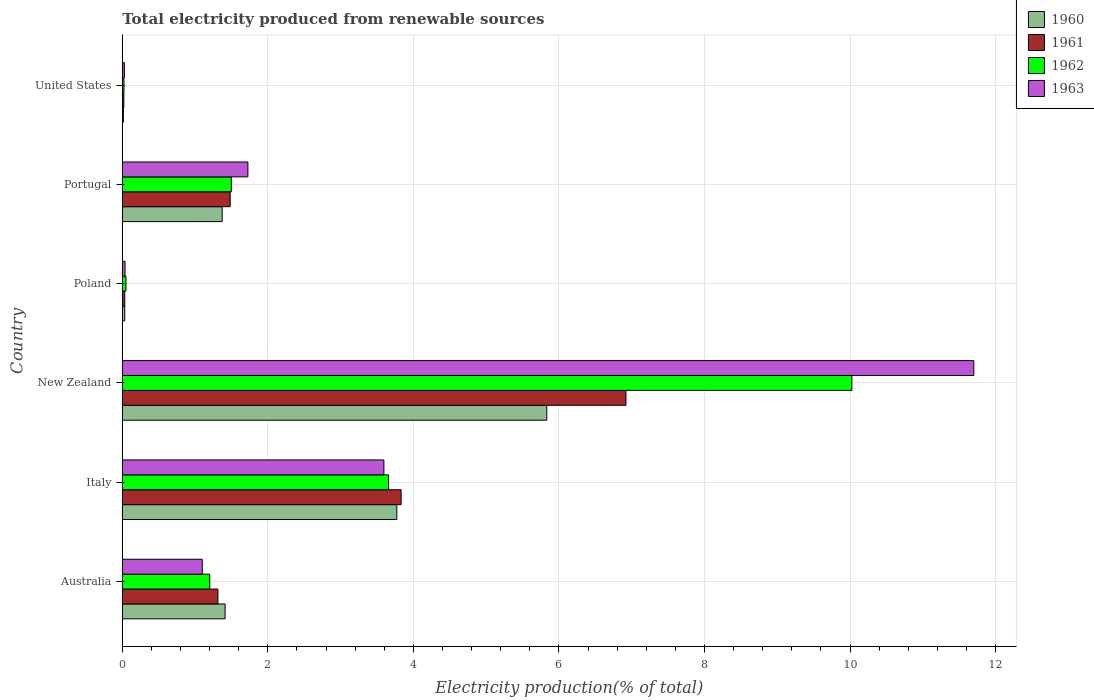Are the number of bars per tick equal to the number of legend labels?
Give a very brief answer. Yes. How many bars are there on the 2nd tick from the top?
Make the answer very short. 4. How many bars are there on the 2nd tick from the bottom?
Your answer should be compact. 4. What is the label of the 6th group of bars from the top?
Give a very brief answer. Australia. What is the total electricity produced in 1962 in United States?
Give a very brief answer. 0.02. Across all countries, what is the maximum total electricity produced in 1961?
Offer a terse response. 6.92. Across all countries, what is the minimum total electricity produced in 1963?
Offer a very short reply. 0.03. In which country was the total electricity produced in 1960 maximum?
Provide a short and direct response. New Zealand. What is the total total electricity produced in 1962 in the graph?
Keep it short and to the point. 16.46. What is the difference between the total electricity produced in 1963 in Australia and that in Poland?
Provide a succinct answer. 1.06. What is the difference between the total electricity produced in 1960 in Poland and the total electricity produced in 1961 in New Zealand?
Offer a very short reply. -6.89. What is the average total electricity produced in 1963 per country?
Your answer should be very brief. 3.03. What is the difference between the total electricity produced in 1961 and total electricity produced in 1960 in Poland?
Your answer should be very brief. -3.156606850160393e-5. What is the ratio of the total electricity produced in 1961 in Italy to that in Portugal?
Your answer should be very brief. 2.58. Is the total electricity produced in 1962 in Italy less than that in United States?
Offer a very short reply. No. What is the difference between the highest and the second highest total electricity produced in 1962?
Offer a very short reply. 6.37. What is the difference between the highest and the lowest total electricity produced in 1960?
Make the answer very short. 5.82. In how many countries, is the total electricity produced in 1960 greater than the average total electricity produced in 1960 taken over all countries?
Ensure brevity in your answer.  2. Is the sum of the total electricity produced in 1963 in Italy and New Zealand greater than the maximum total electricity produced in 1960 across all countries?
Ensure brevity in your answer.  Yes. Is it the case that in every country, the sum of the total electricity produced in 1961 and total electricity produced in 1960 is greater than the sum of total electricity produced in 1962 and total electricity produced in 1963?
Your answer should be very brief. No. Is it the case that in every country, the sum of the total electricity produced in 1963 and total electricity produced in 1962 is greater than the total electricity produced in 1960?
Provide a succinct answer. Yes. Are all the bars in the graph horizontal?
Provide a short and direct response. Yes. What is the difference between two consecutive major ticks on the X-axis?
Offer a terse response. 2. Are the values on the major ticks of X-axis written in scientific E-notation?
Provide a short and direct response. No. Where does the legend appear in the graph?
Provide a short and direct response. Top right. How are the legend labels stacked?
Offer a very short reply. Vertical. What is the title of the graph?
Your answer should be compact. Total electricity produced from renewable sources. Does "2013" appear as one of the legend labels in the graph?
Make the answer very short. No. What is the label or title of the X-axis?
Give a very brief answer. Electricity production(% of total). What is the Electricity production(% of total) of 1960 in Australia?
Offer a terse response. 1.41. What is the Electricity production(% of total) in 1961 in Australia?
Your response must be concise. 1.31. What is the Electricity production(% of total) in 1962 in Australia?
Provide a succinct answer. 1.2. What is the Electricity production(% of total) in 1963 in Australia?
Your answer should be very brief. 1.1. What is the Electricity production(% of total) of 1960 in Italy?
Your answer should be very brief. 3.77. What is the Electricity production(% of total) of 1961 in Italy?
Provide a short and direct response. 3.83. What is the Electricity production(% of total) in 1962 in Italy?
Give a very brief answer. 3.66. What is the Electricity production(% of total) of 1963 in Italy?
Your answer should be compact. 3.59. What is the Electricity production(% of total) of 1960 in New Zealand?
Offer a very short reply. 5.83. What is the Electricity production(% of total) in 1961 in New Zealand?
Provide a succinct answer. 6.92. What is the Electricity production(% of total) in 1962 in New Zealand?
Offer a terse response. 10.02. What is the Electricity production(% of total) of 1963 in New Zealand?
Provide a succinct answer. 11.7. What is the Electricity production(% of total) of 1960 in Poland?
Your answer should be very brief. 0.03. What is the Electricity production(% of total) in 1961 in Poland?
Offer a very short reply. 0.03. What is the Electricity production(% of total) of 1962 in Poland?
Keep it short and to the point. 0.05. What is the Electricity production(% of total) of 1963 in Poland?
Your answer should be very brief. 0.04. What is the Electricity production(% of total) of 1960 in Portugal?
Provide a succinct answer. 1.37. What is the Electricity production(% of total) in 1961 in Portugal?
Give a very brief answer. 1.48. What is the Electricity production(% of total) in 1962 in Portugal?
Provide a short and direct response. 1.5. What is the Electricity production(% of total) of 1963 in Portugal?
Your response must be concise. 1.73. What is the Electricity production(% of total) of 1960 in United States?
Offer a very short reply. 0.02. What is the Electricity production(% of total) in 1961 in United States?
Offer a very short reply. 0.02. What is the Electricity production(% of total) of 1962 in United States?
Ensure brevity in your answer.  0.02. What is the Electricity production(% of total) of 1963 in United States?
Provide a short and direct response. 0.03. Across all countries, what is the maximum Electricity production(% of total) of 1960?
Provide a succinct answer. 5.83. Across all countries, what is the maximum Electricity production(% of total) of 1961?
Ensure brevity in your answer.  6.92. Across all countries, what is the maximum Electricity production(% of total) of 1962?
Provide a short and direct response. 10.02. Across all countries, what is the maximum Electricity production(% of total) of 1963?
Your answer should be very brief. 11.7. Across all countries, what is the minimum Electricity production(% of total) in 1960?
Offer a very short reply. 0.02. Across all countries, what is the minimum Electricity production(% of total) of 1961?
Give a very brief answer. 0.02. Across all countries, what is the minimum Electricity production(% of total) in 1962?
Offer a terse response. 0.02. Across all countries, what is the minimum Electricity production(% of total) of 1963?
Offer a very short reply. 0.03. What is the total Electricity production(% of total) in 1960 in the graph?
Provide a succinct answer. 12.44. What is the total Electricity production(% of total) in 1961 in the graph?
Ensure brevity in your answer.  13.6. What is the total Electricity production(% of total) in 1962 in the graph?
Ensure brevity in your answer.  16.46. What is the total Electricity production(% of total) of 1963 in the graph?
Your answer should be compact. 18.19. What is the difference between the Electricity production(% of total) in 1960 in Australia and that in Italy?
Offer a terse response. -2.36. What is the difference between the Electricity production(% of total) of 1961 in Australia and that in Italy?
Provide a succinct answer. -2.52. What is the difference between the Electricity production(% of total) in 1962 in Australia and that in Italy?
Give a very brief answer. -2.46. What is the difference between the Electricity production(% of total) of 1963 in Australia and that in Italy?
Provide a succinct answer. -2.5. What is the difference between the Electricity production(% of total) of 1960 in Australia and that in New Zealand?
Your answer should be very brief. -4.42. What is the difference between the Electricity production(% of total) of 1961 in Australia and that in New Zealand?
Your answer should be compact. -5.61. What is the difference between the Electricity production(% of total) in 1962 in Australia and that in New Zealand?
Make the answer very short. -8.82. What is the difference between the Electricity production(% of total) in 1963 in Australia and that in New Zealand?
Ensure brevity in your answer.  -10.6. What is the difference between the Electricity production(% of total) of 1960 in Australia and that in Poland?
Your response must be concise. 1.38. What is the difference between the Electricity production(% of total) of 1961 in Australia and that in Poland?
Your answer should be compact. 1.28. What is the difference between the Electricity production(% of total) of 1962 in Australia and that in Poland?
Make the answer very short. 1.15. What is the difference between the Electricity production(% of total) in 1963 in Australia and that in Poland?
Provide a succinct answer. 1.06. What is the difference between the Electricity production(% of total) in 1960 in Australia and that in Portugal?
Offer a very short reply. 0.04. What is the difference between the Electricity production(% of total) in 1961 in Australia and that in Portugal?
Offer a very short reply. -0.17. What is the difference between the Electricity production(% of total) in 1962 in Australia and that in Portugal?
Your response must be concise. -0.3. What is the difference between the Electricity production(% of total) in 1963 in Australia and that in Portugal?
Make the answer very short. -0.63. What is the difference between the Electricity production(% of total) of 1960 in Australia and that in United States?
Give a very brief answer. 1.4. What is the difference between the Electricity production(% of total) of 1961 in Australia and that in United States?
Make the answer very short. 1.29. What is the difference between the Electricity production(% of total) of 1962 in Australia and that in United States?
Make the answer very short. 1.18. What is the difference between the Electricity production(% of total) of 1963 in Australia and that in United States?
Ensure brevity in your answer.  1.07. What is the difference between the Electricity production(% of total) in 1960 in Italy and that in New Zealand?
Your answer should be very brief. -2.06. What is the difference between the Electricity production(% of total) of 1961 in Italy and that in New Zealand?
Your answer should be compact. -3.09. What is the difference between the Electricity production(% of total) in 1962 in Italy and that in New Zealand?
Keep it short and to the point. -6.37. What is the difference between the Electricity production(% of total) of 1963 in Italy and that in New Zealand?
Your answer should be compact. -8.11. What is the difference between the Electricity production(% of total) of 1960 in Italy and that in Poland?
Make the answer very short. 3.74. What is the difference between the Electricity production(% of total) of 1961 in Italy and that in Poland?
Your answer should be very brief. 3.8. What is the difference between the Electricity production(% of total) in 1962 in Italy and that in Poland?
Your answer should be compact. 3.61. What is the difference between the Electricity production(% of total) of 1963 in Italy and that in Poland?
Offer a terse response. 3.56. What is the difference between the Electricity production(% of total) in 1960 in Italy and that in Portugal?
Your answer should be compact. 2.4. What is the difference between the Electricity production(% of total) of 1961 in Italy and that in Portugal?
Keep it short and to the point. 2.35. What is the difference between the Electricity production(% of total) in 1962 in Italy and that in Portugal?
Ensure brevity in your answer.  2.16. What is the difference between the Electricity production(% of total) of 1963 in Italy and that in Portugal?
Provide a succinct answer. 1.87. What is the difference between the Electricity production(% of total) in 1960 in Italy and that in United States?
Provide a succinct answer. 3.76. What is the difference between the Electricity production(% of total) of 1961 in Italy and that in United States?
Ensure brevity in your answer.  3.81. What is the difference between the Electricity production(% of total) of 1962 in Italy and that in United States?
Give a very brief answer. 3.64. What is the difference between the Electricity production(% of total) in 1963 in Italy and that in United States?
Your response must be concise. 3.56. What is the difference between the Electricity production(% of total) in 1960 in New Zealand and that in Poland?
Offer a terse response. 5.8. What is the difference between the Electricity production(% of total) of 1961 in New Zealand and that in Poland?
Provide a short and direct response. 6.89. What is the difference between the Electricity production(% of total) in 1962 in New Zealand and that in Poland?
Give a very brief answer. 9.97. What is the difference between the Electricity production(% of total) in 1963 in New Zealand and that in Poland?
Your response must be concise. 11.66. What is the difference between the Electricity production(% of total) of 1960 in New Zealand and that in Portugal?
Ensure brevity in your answer.  4.46. What is the difference between the Electricity production(% of total) of 1961 in New Zealand and that in Portugal?
Make the answer very short. 5.44. What is the difference between the Electricity production(% of total) in 1962 in New Zealand and that in Portugal?
Make the answer very short. 8.53. What is the difference between the Electricity production(% of total) in 1963 in New Zealand and that in Portugal?
Offer a terse response. 9.97. What is the difference between the Electricity production(% of total) in 1960 in New Zealand and that in United States?
Provide a short and direct response. 5.82. What is the difference between the Electricity production(% of total) in 1961 in New Zealand and that in United States?
Your answer should be compact. 6.9. What is the difference between the Electricity production(% of total) of 1962 in New Zealand and that in United States?
Offer a terse response. 10. What is the difference between the Electricity production(% of total) of 1963 in New Zealand and that in United States?
Make the answer very short. 11.67. What is the difference between the Electricity production(% of total) in 1960 in Poland and that in Portugal?
Keep it short and to the point. -1.34. What is the difference between the Electricity production(% of total) in 1961 in Poland and that in Portugal?
Make the answer very short. -1.45. What is the difference between the Electricity production(% of total) in 1962 in Poland and that in Portugal?
Keep it short and to the point. -1.45. What is the difference between the Electricity production(% of total) of 1963 in Poland and that in Portugal?
Your response must be concise. -1.69. What is the difference between the Electricity production(% of total) of 1960 in Poland and that in United States?
Your response must be concise. 0.02. What is the difference between the Electricity production(% of total) of 1961 in Poland and that in United States?
Offer a very short reply. 0.01. What is the difference between the Electricity production(% of total) in 1962 in Poland and that in United States?
Your response must be concise. 0.03. What is the difference between the Electricity production(% of total) of 1963 in Poland and that in United States?
Offer a terse response. 0.01. What is the difference between the Electricity production(% of total) of 1960 in Portugal and that in United States?
Your answer should be very brief. 1.36. What is the difference between the Electricity production(% of total) of 1961 in Portugal and that in United States?
Your answer should be compact. 1.46. What is the difference between the Electricity production(% of total) in 1962 in Portugal and that in United States?
Ensure brevity in your answer.  1.48. What is the difference between the Electricity production(% of total) of 1963 in Portugal and that in United States?
Your response must be concise. 1.7. What is the difference between the Electricity production(% of total) of 1960 in Australia and the Electricity production(% of total) of 1961 in Italy?
Your answer should be very brief. -2.42. What is the difference between the Electricity production(% of total) of 1960 in Australia and the Electricity production(% of total) of 1962 in Italy?
Your answer should be very brief. -2.25. What is the difference between the Electricity production(% of total) in 1960 in Australia and the Electricity production(% of total) in 1963 in Italy?
Make the answer very short. -2.18. What is the difference between the Electricity production(% of total) of 1961 in Australia and the Electricity production(% of total) of 1962 in Italy?
Ensure brevity in your answer.  -2.34. What is the difference between the Electricity production(% of total) of 1961 in Australia and the Electricity production(% of total) of 1963 in Italy?
Keep it short and to the point. -2.28. What is the difference between the Electricity production(% of total) in 1962 in Australia and the Electricity production(% of total) in 1963 in Italy?
Give a very brief answer. -2.39. What is the difference between the Electricity production(% of total) in 1960 in Australia and the Electricity production(% of total) in 1961 in New Zealand?
Your answer should be very brief. -5.51. What is the difference between the Electricity production(% of total) in 1960 in Australia and the Electricity production(% of total) in 1962 in New Zealand?
Your answer should be very brief. -8.61. What is the difference between the Electricity production(% of total) of 1960 in Australia and the Electricity production(% of total) of 1963 in New Zealand?
Keep it short and to the point. -10.29. What is the difference between the Electricity production(% of total) in 1961 in Australia and the Electricity production(% of total) in 1962 in New Zealand?
Offer a terse response. -8.71. What is the difference between the Electricity production(% of total) in 1961 in Australia and the Electricity production(% of total) in 1963 in New Zealand?
Offer a terse response. -10.39. What is the difference between the Electricity production(% of total) in 1962 in Australia and the Electricity production(% of total) in 1963 in New Zealand?
Your answer should be compact. -10.5. What is the difference between the Electricity production(% of total) of 1960 in Australia and the Electricity production(% of total) of 1961 in Poland?
Give a very brief answer. 1.38. What is the difference between the Electricity production(% of total) in 1960 in Australia and the Electricity production(% of total) in 1962 in Poland?
Offer a terse response. 1.36. What is the difference between the Electricity production(% of total) in 1960 in Australia and the Electricity production(% of total) in 1963 in Poland?
Make the answer very short. 1.37. What is the difference between the Electricity production(% of total) of 1961 in Australia and the Electricity production(% of total) of 1962 in Poland?
Your response must be concise. 1.26. What is the difference between the Electricity production(% of total) of 1961 in Australia and the Electricity production(% of total) of 1963 in Poland?
Keep it short and to the point. 1.28. What is the difference between the Electricity production(% of total) of 1962 in Australia and the Electricity production(% of total) of 1963 in Poland?
Provide a succinct answer. 1.16. What is the difference between the Electricity production(% of total) of 1960 in Australia and the Electricity production(% of total) of 1961 in Portugal?
Keep it short and to the point. -0.07. What is the difference between the Electricity production(% of total) in 1960 in Australia and the Electricity production(% of total) in 1962 in Portugal?
Your answer should be compact. -0.09. What is the difference between the Electricity production(% of total) of 1960 in Australia and the Electricity production(% of total) of 1963 in Portugal?
Make the answer very short. -0.31. What is the difference between the Electricity production(% of total) in 1961 in Australia and the Electricity production(% of total) in 1962 in Portugal?
Provide a succinct answer. -0.18. What is the difference between the Electricity production(% of total) of 1961 in Australia and the Electricity production(% of total) of 1963 in Portugal?
Provide a short and direct response. -0.41. What is the difference between the Electricity production(% of total) of 1962 in Australia and the Electricity production(% of total) of 1963 in Portugal?
Your answer should be very brief. -0.52. What is the difference between the Electricity production(% of total) of 1960 in Australia and the Electricity production(% of total) of 1961 in United States?
Your response must be concise. 1.39. What is the difference between the Electricity production(% of total) in 1960 in Australia and the Electricity production(% of total) in 1962 in United States?
Your response must be concise. 1.39. What is the difference between the Electricity production(% of total) in 1960 in Australia and the Electricity production(% of total) in 1963 in United States?
Ensure brevity in your answer.  1.38. What is the difference between the Electricity production(% of total) of 1961 in Australia and the Electricity production(% of total) of 1962 in United States?
Your response must be concise. 1.29. What is the difference between the Electricity production(% of total) of 1961 in Australia and the Electricity production(% of total) of 1963 in United States?
Offer a terse response. 1.28. What is the difference between the Electricity production(% of total) of 1962 in Australia and the Electricity production(% of total) of 1963 in United States?
Ensure brevity in your answer.  1.17. What is the difference between the Electricity production(% of total) of 1960 in Italy and the Electricity production(% of total) of 1961 in New Zealand?
Offer a very short reply. -3.15. What is the difference between the Electricity production(% of total) in 1960 in Italy and the Electricity production(% of total) in 1962 in New Zealand?
Your answer should be compact. -6.25. What is the difference between the Electricity production(% of total) of 1960 in Italy and the Electricity production(% of total) of 1963 in New Zealand?
Ensure brevity in your answer.  -7.93. What is the difference between the Electricity production(% of total) of 1961 in Italy and the Electricity production(% of total) of 1962 in New Zealand?
Provide a succinct answer. -6.19. What is the difference between the Electricity production(% of total) of 1961 in Italy and the Electricity production(% of total) of 1963 in New Zealand?
Your answer should be very brief. -7.87. What is the difference between the Electricity production(% of total) of 1962 in Italy and the Electricity production(% of total) of 1963 in New Zealand?
Ensure brevity in your answer.  -8.04. What is the difference between the Electricity production(% of total) in 1960 in Italy and the Electricity production(% of total) in 1961 in Poland?
Give a very brief answer. 3.74. What is the difference between the Electricity production(% of total) of 1960 in Italy and the Electricity production(% of total) of 1962 in Poland?
Offer a very short reply. 3.72. What is the difference between the Electricity production(% of total) of 1960 in Italy and the Electricity production(% of total) of 1963 in Poland?
Keep it short and to the point. 3.73. What is the difference between the Electricity production(% of total) of 1961 in Italy and the Electricity production(% of total) of 1962 in Poland?
Keep it short and to the point. 3.78. What is the difference between the Electricity production(% of total) of 1961 in Italy and the Electricity production(% of total) of 1963 in Poland?
Make the answer very short. 3.79. What is the difference between the Electricity production(% of total) in 1962 in Italy and the Electricity production(% of total) in 1963 in Poland?
Make the answer very short. 3.62. What is the difference between the Electricity production(% of total) of 1960 in Italy and the Electricity production(% of total) of 1961 in Portugal?
Your response must be concise. 2.29. What is the difference between the Electricity production(% of total) of 1960 in Italy and the Electricity production(% of total) of 1962 in Portugal?
Provide a succinct answer. 2.27. What is the difference between the Electricity production(% of total) in 1960 in Italy and the Electricity production(% of total) in 1963 in Portugal?
Make the answer very short. 2.05. What is the difference between the Electricity production(% of total) of 1961 in Italy and the Electricity production(% of total) of 1962 in Portugal?
Make the answer very short. 2.33. What is the difference between the Electricity production(% of total) in 1961 in Italy and the Electricity production(% of total) in 1963 in Portugal?
Provide a short and direct response. 2.11. What is the difference between the Electricity production(% of total) of 1962 in Italy and the Electricity production(% of total) of 1963 in Portugal?
Your answer should be compact. 1.93. What is the difference between the Electricity production(% of total) in 1960 in Italy and the Electricity production(% of total) in 1961 in United States?
Ensure brevity in your answer.  3.75. What is the difference between the Electricity production(% of total) in 1960 in Italy and the Electricity production(% of total) in 1962 in United States?
Your answer should be compact. 3.75. What is the difference between the Electricity production(% of total) of 1960 in Italy and the Electricity production(% of total) of 1963 in United States?
Your answer should be compact. 3.74. What is the difference between the Electricity production(% of total) in 1961 in Italy and the Electricity production(% of total) in 1962 in United States?
Ensure brevity in your answer.  3.81. What is the difference between the Electricity production(% of total) of 1961 in Italy and the Electricity production(% of total) of 1963 in United States?
Make the answer very short. 3.8. What is the difference between the Electricity production(% of total) of 1962 in Italy and the Electricity production(% of total) of 1963 in United States?
Ensure brevity in your answer.  3.63. What is the difference between the Electricity production(% of total) in 1960 in New Zealand and the Electricity production(% of total) in 1961 in Poland?
Keep it short and to the point. 5.8. What is the difference between the Electricity production(% of total) in 1960 in New Zealand and the Electricity production(% of total) in 1962 in Poland?
Keep it short and to the point. 5.78. What is the difference between the Electricity production(% of total) of 1960 in New Zealand and the Electricity production(% of total) of 1963 in Poland?
Make the answer very short. 5.79. What is the difference between the Electricity production(% of total) of 1961 in New Zealand and the Electricity production(% of total) of 1962 in Poland?
Provide a short and direct response. 6.87. What is the difference between the Electricity production(% of total) in 1961 in New Zealand and the Electricity production(% of total) in 1963 in Poland?
Provide a succinct answer. 6.88. What is the difference between the Electricity production(% of total) in 1962 in New Zealand and the Electricity production(% of total) in 1963 in Poland?
Provide a short and direct response. 9.99. What is the difference between the Electricity production(% of total) of 1960 in New Zealand and the Electricity production(% of total) of 1961 in Portugal?
Give a very brief answer. 4.35. What is the difference between the Electricity production(% of total) in 1960 in New Zealand and the Electricity production(% of total) in 1962 in Portugal?
Your answer should be very brief. 4.33. What is the difference between the Electricity production(% of total) in 1960 in New Zealand and the Electricity production(% of total) in 1963 in Portugal?
Provide a short and direct response. 4.11. What is the difference between the Electricity production(% of total) of 1961 in New Zealand and the Electricity production(% of total) of 1962 in Portugal?
Keep it short and to the point. 5.42. What is the difference between the Electricity production(% of total) in 1961 in New Zealand and the Electricity production(% of total) in 1963 in Portugal?
Offer a terse response. 5.19. What is the difference between the Electricity production(% of total) in 1962 in New Zealand and the Electricity production(% of total) in 1963 in Portugal?
Give a very brief answer. 8.3. What is the difference between the Electricity production(% of total) in 1960 in New Zealand and the Electricity production(% of total) in 1961 in United States?
Provide a short and direct response. 5.81. What is the difference between the Electricity production(% of total) in 1960 in New Zealand and the Electricity production(% of total) in 1962 in United States?
Provide a short and direct response. 5.81. What is the difference between the Electricity production(% of total) of 1960 in New Zealand and the Electricity production(% of total) of 1963 in United States?
Offer a terse response. 5.8. What is the difference between the Electricity production(% of total) in 1961 in New Zealand and the Electricity production(% of total) in 1962 in United States?
Your response must be concise. 6.9. What is the difference between the Electricity production(% of total) in 1961 in New Zealand and the Electricity production(% of total) in 1963 in United States?
Ensure brevity in your answer.  6.89. What is the difference between the Electricity production(% of total) of 1962 in New Zealand and the Electricity production(% of total) of 1963 in United States?
Provide a short and direct response. 10. What is the difference between the Electricity production(% of total) in 1960 in Poland and the Electricity production(% of total) in 1961 in Portugal?
Give a very brief answer. -1.45. What is the difference between the Electricity production(% of total) of 1960 in Poland and the Electricity production(% of total) of 1962 in Portugal?
Make the answer very short. -1.46. What is the difference between the Electricity production(% of total) of 1960 in Poland and the Electricity production(% of total) of 1963 in Portugal?
Your response must be concise. -1.69. What is the difference between the Electricity production(% of total) in 1961 in Poland and the Electricity production(% of total) in 1962 in Portugal?
Offer a terse response. -1.46. What is the difference between the Electricity production(% of total) of 1961 in Poland and the Electricity production(% of total) of 1963 in Portugal?
Provide a short and direct response. -1.69. What is the difference between the Electricity production(% of total) in 1962 in Poland and the Electricity production(% of total) in 1963 in Portugal?
Your response must be concise. -1.67. What is the difference between the Electricity production(% of total) of 1960 in Poland and the Electricity production(% of total) of 1961 in United States?
Make the answer very short. 0.01. What is the difference between the Electricity production(% of total) in 1960 in Poland and the Electricity production(% of total) in 1962 in United States?
Offer a terse response. 0.01. What is the difference between the Electricity production(% of total) of 1960 in Poland and the Electricity production(% of total) of 1963 in United States?
Offer a very short reply. 0. What is the difference between the Electricity production(% of total) in 1961 in Poland and the Electricity production(% of total) in 1962 in United States?
Offer a very short reply. 0.01. What is the difference between the Electricity production(% of total) of 1961 in Poland and the Electricity production(% of total) of 1963 in United States?
Ensure brevity in your answer.  0. What is the difference between the Electricity production(% of total) of 1962 in Poland and the Electricity production(% of total) of 1963 in United States?
Make the answer very short. 0.02. What is the difference between the Electricity production(% of total) of 1960 in Portugal and the Electricity production(% of total) of 1961 in United States?
Your response must be concise. 1.35. What is the difference between the Electricity production(% of total) of 1960 in Portugal and the Electricity production(% of total) of 1962 in United States?
Make the answer very short. 1.35. What is the difference between the Electricity production(% of total) of 1960 in Portugal and the Electricity production(% of total) of 1963 in United States?
Your answer should be very brief. 1.34. What is the difference between the Electricity production(% of total) in 1961 in Portugal and the Electricity production(% of total) in 1962 in United States?
Provide a succinct answer. 1.46. What is the difference between the Electricity production(% of total) in 1961 in Portugal and the Electricity production(% of total) in 1963 in United States?
Your response must be concise. 1.45. What is the difference between the Electricity production(% of total) of 1962 in Portugal and the Electricity production(% of total) of 1963 in United States?
Offer a terse response. 1.47. What is the average Electricity production(% of total) of 1960 per country?
Offer a very short reply. 2.07. What is the average Electricity production(% of total) in 1961 per country?
Ensure brevity in your answer.  2.27. What is the average Electricity production(% of total) of 1962 per country?
Offer a very short reply. 2.74. What is the average Electricity production(% of total) of 1963 per country?
Offer a terse response. 3.03. What is the difference between the Electricity production(% of total) in 1960 and Electricity production(% of total) in 1961 in Australia?
Your answer should be very brief. 0.1. What is the difference between the Electricity production(% of total) in 1960 and Electricity production(% of total) in 1962 in Australia?
Give a very brief answer. 0.21. What is the difference between the Electricity production(% of total) of 1960 and Electricity production(% of total) of 1963 in Australia?
Offer a terse response. 0.31. What is the difference between the Electricity production(% of total) of 1961 and Electricity production(% of total) of 1962 in Australia?
Ensure brevity in your answer.  0.11. What is the difference between the Electricity production(% of total) of 1961 and Electricity production(% of total) of 1963 in Australia?
Make the answer very short. 0.21. What is the difference between the Electricity production(% of total) in 1962 and Electricity production(% of total) in 1963 in Australia?
Your answer should be compact. 0.1. What is the difference between the Electricity production(% of total) in 1960 and Electricity production(% of total) in 1961 in Italy?
Provide a succinct answer. -0.06. What is the difference between the Electricity production(% of total) in 1960 and Electricity production(% of total) in 1962 in Italy?
Keep it short and to the point. 0.11. What is the difference between the Electricity production(% of total) of 1960 and Electricity production(% of total) of 1963 in Italy?
Your answer should be compact. 0.18. What is the difference between the Electricity production(% of total) of 1961 and Electricity production(% of total) of 1962 in Italy?
Provide a short and direct response. 0.17. What is the difference between the Electricity production(% of total) of 1961 and Electricity production(% of total) of 1963 in Italy?
Make the answer very short. 0.24. What is the difference between the Electricity production(% of total) in 1962 and Electricity production(% of total) in 1963 in Italy?
Offer a terse response. 0.06. What is the difference between the Electricity production(% of total) in 1960 and Electricity production(% of total) in 1961 in New Zealand?
Provide a short and direct response. -1.09. What is the difference between the Electricity production(% of total) in 1960 and Electricity production(% of total) in 1962 in New Zealand?
Offer a very short reply. -4.19. What is the difference between the Electricity production(% of total) of 1960 and Electricity production(% of total) of 1963 in New Zealand?
Provide a short and direct response. -5.87. What is the difference between the Electricity production(% of total) of 1961 and Electricity production(% of total) of 1962 in New Zealand?
Offer a terse response. -3.1. What is the difference between the Electricity production(% of total) of 1961 and Electricity production(% of total) of 1963 in New Zealand?
Give a very brief answer. -4.78. What is the difference between the Electricity production(% of total) of 1962 and Electricity production(% of total) of 1963 in New Zealand?
Your response must be concise. -1.68. What is the difference between the Electricity production(% of total) of 1960 and Electricity production(% of total) of 1962 in Poland?
Offer a terse response. -0.02. What is the difference between the Electricity production(% of total) in 1960 and Electricity production(% of total) in 1963 in Poland?
Provide a short and direct response. -0. What is the difference between the Electricity production(% of total) of 1961 and Electricity production(% of total) of 1962 in Poland?
Your answer should be very brief. -0.02. What is the difference between the Electricity production(% of total) of 1961 and Electricity production(% of total) of 1963 in Poland?
Offer a terse response. -0. What is the difference between the Electricity production(% of total) of 1962 and Electricity production(% of total) of 1963 in Poland?
Give a very brief answer. 0.01. What is the difference between the Electricity production(% of total) in 1960 and Electricity production(% of total) in 1961 in Portugal?
Ensure brevity in your answer.  -0.11. What is the difference between the Electricity production(% of total) in 1960 and Electricity production(% of total) in 1962 in Portugal?
Give a very brief answer. -0.13. What is the difference between the Electricity production(% of total) in 1960 and Electricity production(% of total) in 1963 in Portugal?
Your response must be concise. -0.35. What is the difference between the Electricity production(% of total) of 1961 and Electricity production(% of total) of 1962 in Portugal?
Give a very brief answer. -0.02. What is the difference between the Electricity production(% of total) of 1961 and Electricity production(% of total) of 1963 in Portugal?
Provide a succinct answer. -0.24. What is the difference between the Electricity production(% of total) of 1962 and Electricity production(% of total) of 1963 in Portugal?
Offer a terse response. -0.23. What is the difference between the Electricity production(% of total) in 1960 and Electricity production(% of total) in 1961 in United States?
Provide a short and direct response. -0.01. What is the difference between the Electricity production(% of total) of 1960 and Electricity production(% of total) of 1962 in United States?
Offer a very short reply. -0.01. What is the difference between the Electricity production(% of total) of 1960 and Electricity production(% of total) of 1963 in United States?
Offer a very short reply. -0.01. What is the difference between the Electricity production(% of total) in 1961 and Electricity production(% of total) in 1962 in United States?
Provide a short and direct response. -0. What is the difference between the Electricity production(% of total) of 1961 and Electricity production(% of total) of 1963 in United States?
Your answer should be very brief. -0.01. What is the difference between the Electricity production(% of total) of 1962 and Electricity production(% of total) of 1963 in United States?
Offer a terse response. -0.01. What is the ratio of the Electricity production(% of total) in 1960 in Australia to that in Italy?
Offer a terse response. 0.37. What is the ratio of the Electricity production(% of total) of 1961 in Australia to that in Italy?
Provide a short and direct response. 0.34. What is the ratio of the Electricity production(% of total) of 1962 in Australia to that in Italy?
Make the answer very short. 0.33. What is the ratio of the Electricity production(% of total) of 1963 in Australia to that in Italy?
Your response must be concise. 0.31. What is the ratio of the Electricity production(% of total) of 1960 in Australia to that in New Zealand?
Make the answer very short. 0.24. What is the ratio of the Electricity production(% of total) in 1961 in Australia to that in New Zealand?
Provide a short and direct response. 0.19. What is the ratio of the Electricity production(% of total) in 1962 in Australia to that in New Zealand?
Ensure brevity in your answer.  0.12. What is the ratio of the Electricity production(% of total) of 1963 in Australia to that in New Zealand?
Give a very brief answer. 0.09. What is the ratio of the Electricity production(% of total) in 1960 in Australia to that in Poland?
Your answer should be very brief. 41.37. What is the ratio of the Electricity production(% of total) in 1961 in Australia to that in Poland?
Your response must be concise. 38.51. What is the ratio of the Electricity production(% of total) in 1962 in Australia to that in Poland?
Provide a short and direct response. 23.61. What is the ratio of the Electricity production(% of total) in 1963 in Australia to that in Poland?
Keep it short and to the point. 29. What is the ratio of the Electricity production(% of total) in 1960 in Australia to that in Portugal?
Your answer should be very brief. 1.03. What is the ratio of the Electricity production(% of total) in 1961 in Australia to that in Portugal?
Ensure brevity in your answer.  0.89. What is the ratio of the Electricity production(% of total) in 1962 in Australia to that in Portugal?
Offer a very short reply. 0.8. What is the ratio of the Electricity production(% of total) in 1963 in Australia to that in Portugal?
Your answer should be very brief. 0.64. What is the ratio of the Electricity production(% of total) in 1960 in Australia to that in United States?
Give a very brief answer. 92.6. What is the ratio of the Electricity production(% of total) of 1961 in Australia to that in United States?
Ensure brevity in your answer.  61. What is the ratio of the Electricity production(% of total) in 1962 in Australia to that in United States?
Your response must be concise. 52.74. What is the ratio of the Electricity production(% of total) of 1963 in Australia to that in United States?
Provide a succinct answer. 37.34. What is the ratio of the Electricity production(% of total) in 1960 in Italy to that in New Zealand?
Give a very brief answer. 0.65. What is the ratio of the Electricity production(% of total) of 1961 in Italy to that in New Zealand?
Ensure brevity in your answer.  0.55. What is the ratio of the Electricity production(% of total) in 1962 in Italy to that in New Zealand?
Your answer should be very brief. 0.36. What is the ratio of the Electricity production(% of total) of 1963 in Italy to that in New Zealand?
Make the answer very short. 0.31. What is the ratio of the Electricity production(% of total) in 1960 in Italy to that in Poland?
Your answer should be compact. 110.45. What is the ratio of the Electricity production(% of total) of 1961 in Italy to that in Poland?
Provide a succinct answer. 112.3. What is the ratio of the Electricity production(% of total) of 1962 in Italy to that in Poland?
Provide a short and direct response. 71.88. What is the ratio of the Electricity production(% of total) in 1963 in Italy to that in Poland?
Keep it short and to the point. 94.84. What is the ratio of the Electricity production(% of total) in 1960 in Italy to that in Portugal?
Provide a succinct answer. 2.75. What is the ratio of the Electricity production(% of total) of 1961 in Italy to that in Portugal?
Your response must be concise. 2.58. What is the ratio of the Electricity production(% of total) in 1962 in Italy to that in Portugal?
Your answer should be compact. 2.44. What is the ratio of the Electricity production(% of total) of 1963 in Italy to that in Portugal?
Offer a very short reply. 2.08. What is the ratio of the Electricity production(% of total) in 1960 in Italy to that in United States?
Provide a succinct answer. 247.25. What is the ratio of the Electricity production(% of total) in 1961 in Italy to that in United States?
Your answer should be compact. 177.87. What is the ratio of the Electricity production(% of total) of 1962 in Italy to that in United States?
Your response must be concise. 160.56. What is the ratio of the Electricity production(% of total) in 1963 in Italy to that in United States?
Your response must be concise. 122.12. What is the ratio of the Electricity production(% of total) in 1960 in New Zealand to that in Poland?
Ensure brevity in your answer.  170.79. What is the ratio of the Electricity production(% of total) in 1961 in New Zealand to that in Poland?
Keep it short and to the point. 202.83. What is the ratio of the Electricity production(% of total) in 1962 in New Zealand to that in Poland?
Provide a short and direct response. 196.95. What is the ratio of the Electricity production(% of total) of 1963 in New Zealand to that in Poland?
Your answer should be compact. 308.73. What is the ratio of the Electricity production(% of total) in 1960 in New Zealand to that in Portugal?
Make the answer very short. 4.25. What is the ratio of the Electricity production(% of total) of 1961 in New Zealand to that in Portugal?
Offer a very short reply. 4.67. What is the ratio of the Electricity production(% of total) of 1962 in New Zealand to that in Portugal?
Your answer should be compact. 6.69. What is the ratio of the Electricity production(% of total) in 1963 in New Zealand to that in Portugal?
Your response must be concise. 6.78. What is the ratio of the Electricity production(% of total) of 1960 in New Zealand to that in United States?
Your answer should be compact. 382.31. What is the ratio of the Electricity production(% of total) in 1961 in New Zealand to that in United States?
Make the answer very short. 321.25. What is the ratio of the Electricity production(% of total) of 1962 in New Zealand to that in United States?
Make the answer very short. 439.93. What is the ratio of the Electricity production(% of total) in 1963 in New Zealand to that in United States?
Provide a succinct answer. 397.5. What is the ratio of the Electricity production(% of total) of 1960 in Poland to that in Portugal?
Provide a short and direct response. 0.02. What is the ratio of the Electricity production(% of total) in 1961 in Poland to that in Portugal?
Your answer should be very brief. 0.02. What is the ratio of the Electricity production(% of total) of 1962 in Poland to that in Portugal?
Offer a terse response. 0.03. What is the ratio of the Electricity production(% of total) in 1963 in Poland to that in Portugal?
Offer a very short reply. 0.02. What is the ratio of the Electricity production(% of total) of 1960 in Poland to that in United States?
Your answer should be very brief. 2.24. What is the ratio of the Electricity production(% of total) in 1961 in Poland to that in United States?
Your response must be concise. 1.58. What is the ratio of the Electricity production(% of total) of 1962 in Poland to that in United States?
Your answer should be compact. 2.23. What is the ratio of the Electricity production(% of total) of 1963 in Poland to that in United States?
Provide a succinct answer. 1.29. What is the ratio of the Electricity production(% of total) in 1960 in Portugal to that in United States?
Give a very brief answer. 89.96. What is the ratio of the Electricity production(% of total) in 1961 in Portugal to that in United States?
Your answer should be very brief. 68.83. What is the ratio of the Electricity production(% of total) in 1962 in Portugal to that in United States?
Offer a very short reply. 65.74. What is the ratio of the Electricity production(% of total) in 1963 in Portugal to that in United States?
Your answer should be very brief. 58.63. What is the difference between the highest and the second highest Electricity production(% of total) of 1960?
Ensure brevity in your answer.  2.06. What is the difference between the highest and the second highest Electricity production(% of total) in 1961?
Offer a terse response. 3.09. What is the difference between the highest and the second highest Electricity production(% of total) of 1962?
Your response must be concise. 6.37. What is the difference between the highest and the second highest Electricity production(% of total) in 1963?
Keep it short and to the point. 8.11. What is the difference between the highest and the lowest Electricity production(% of total) of 1960?
Offer a very short reply. 5.82. What is the difference between the highest and the lowest Electricity production(% of total) in 1961?
Your answer should be compact. 6.9. What is the difference between the highest and the lowest Electricity production(% of total) of 1962?
Offer a terse response. 10. What is the difference between the highest and the lowest Electricity production(% of total) of 1963?
Your response must be concise. 11.67. 